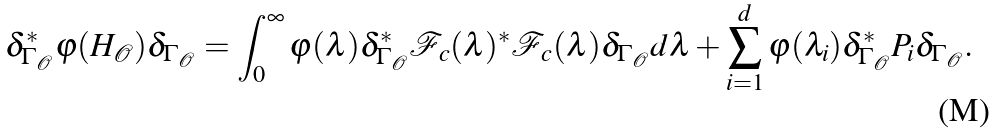<formula> <loc_0><loc_0><loc_500><loc_500>\delta _ { \Gamma _ { \mathcal { O } } } ^ { \ast } \varphi ( H _ { \mathcal { O } } ) \delta _ { \Gamma _ { \mathcal { O } } } = \int _ { 0 } ^ { \infty } \varphi ( \lambda ) \delta _ { \Gamma _ { \mathcal { O } } } ^ { \ast } { \mathcal { F } _ { c } } ( \lambda ) ^ { \ast } { \mathcal { F } _ { c } } ( \lambda ) \delta _ { \Gamma _ { \mathcal { O } } } d \lambda + \sum _ { i = 1 } ^ { d } \varphi ( \lambda _ { i } ) \delta _ { \Gamma _ { \mathcal { O } } } ^ { \ast } P _ { i } \delta _ { \Gamma _ { \mathcal { O } } } .</formula> 